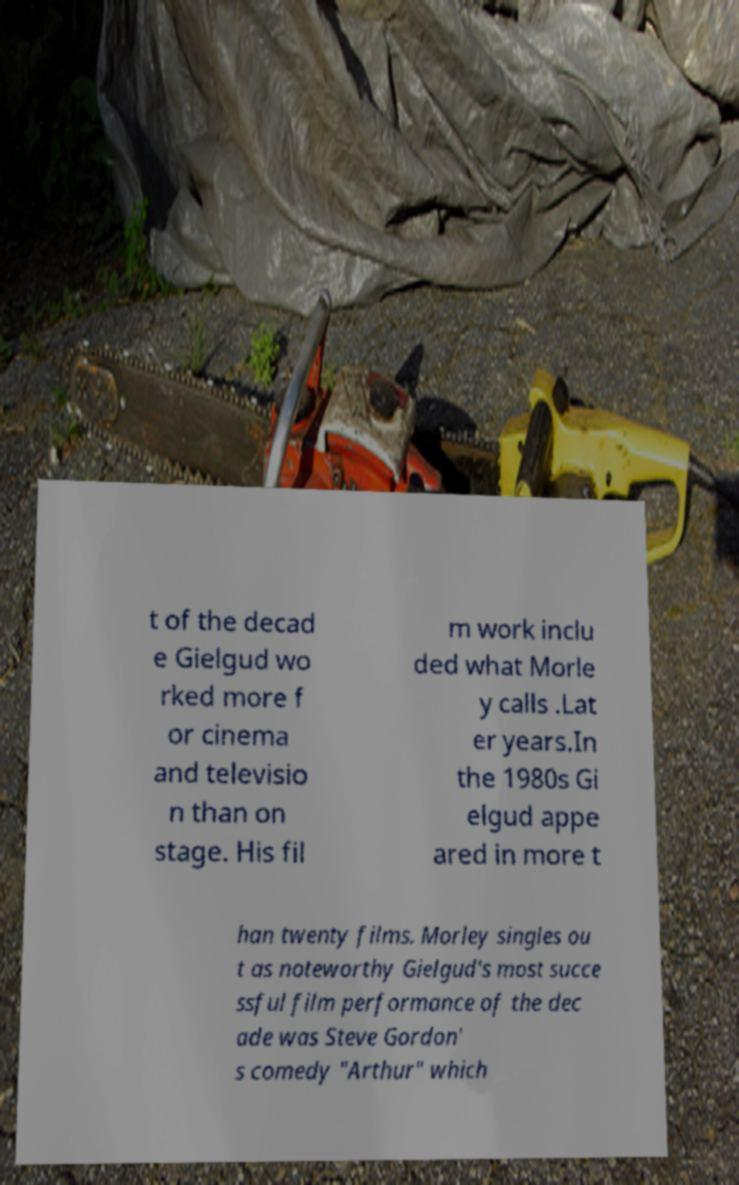I need the written content from this picture converted into text. Can you do that? t of the decad e Gielgud wo rked more f or cinema and televisio n than on stage. His fil m work inclu ded what Morle y calls .Lat er years.In the 1980s Gi elgud appe ared in more t han twenty films. Morley singles ou t as noteworthy Gielgud's most succe ssful film performance of the dec ade was Steve Gordon' s comedy "Arthur" which 